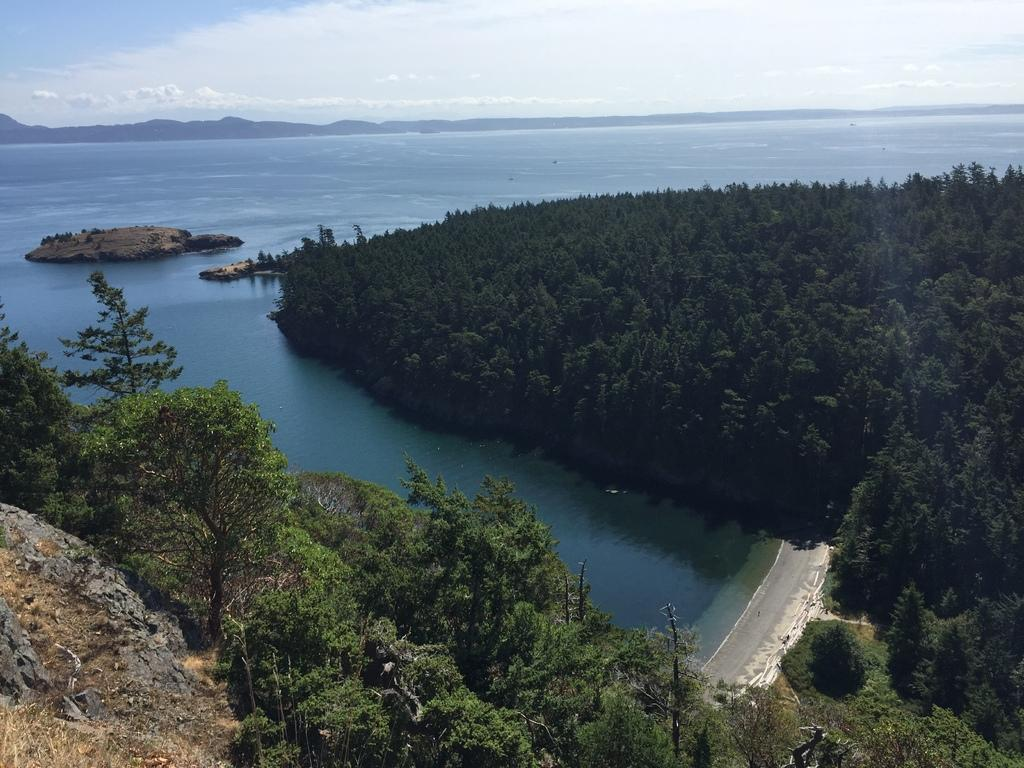What type of vegetation is present in the image? There are trees in the image. What is located at the bottom of the image? There is water at the bottom of the image. What part of the natural environment is visible at the top of the image? The sky is visible at the top of the image. What type of mountain can be seen in the background of the image? There is no mountain present in the image; it only features trees, water, and the sky. What kind of vessel is floating on the water in the image? There is no vessel present in the image; it only features trees, water, and the sky. 